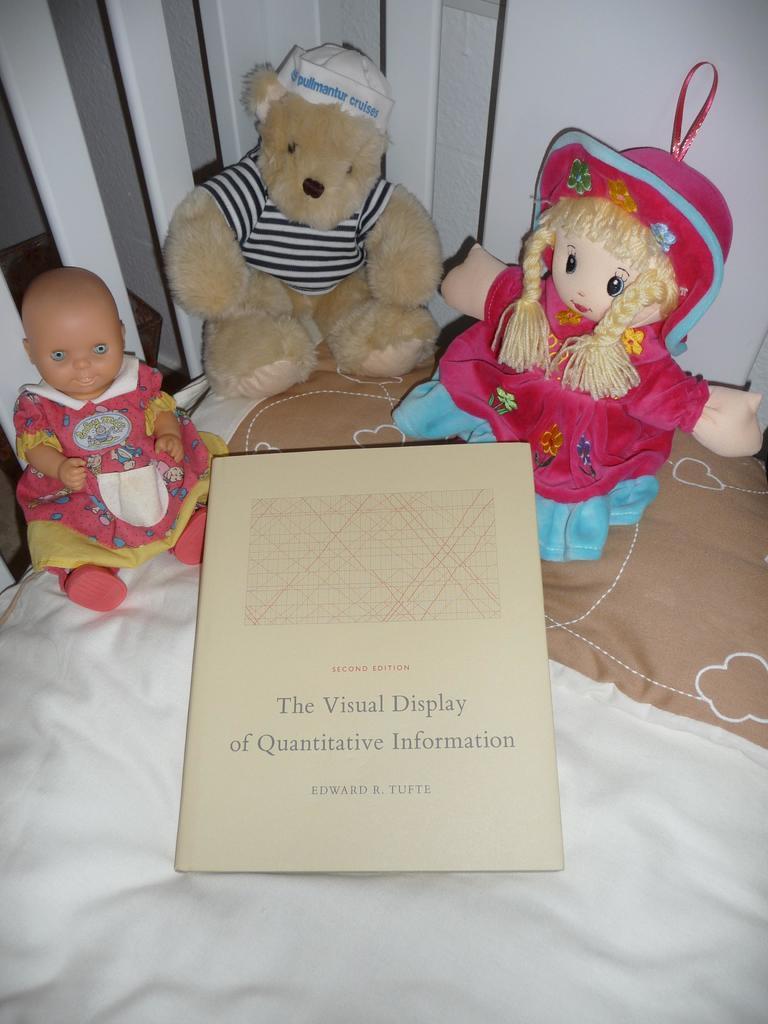Please provide a concise description of this image. In this picture I see a couch on which there are 2 soft toys and a doll and a paper on which there is something written. 